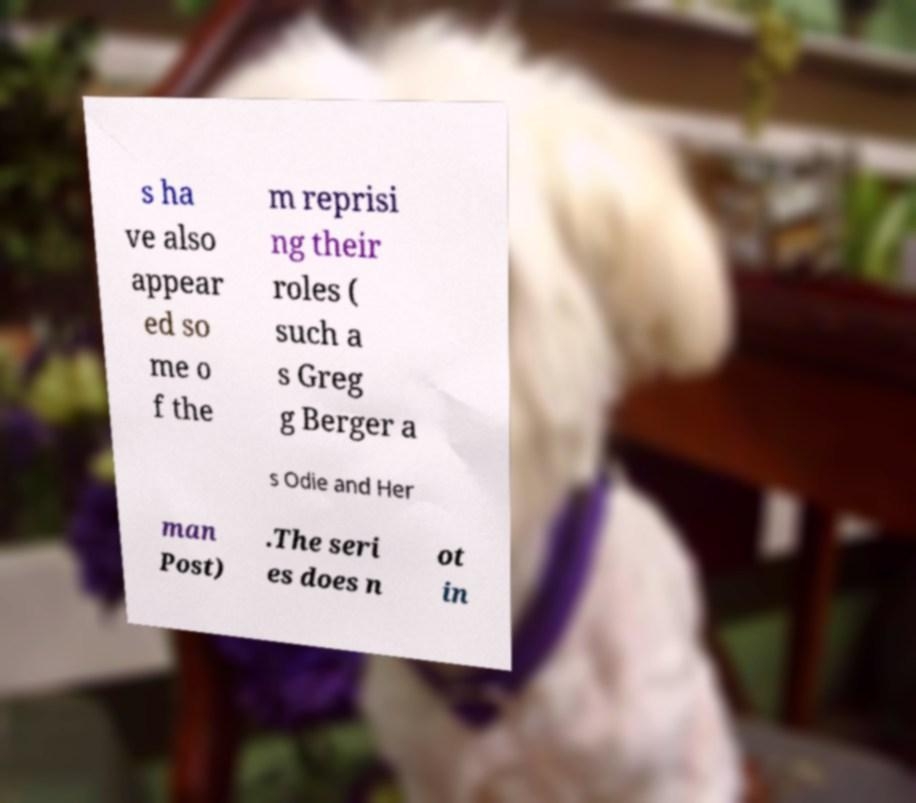I need the written content from this picture converted into text. Can you do that? s ha ve also appear ed so me o f the m reprisi ng their roles ( such a s Greg g Berger a s Odie and Her man Post) .The seri es does n ot in 